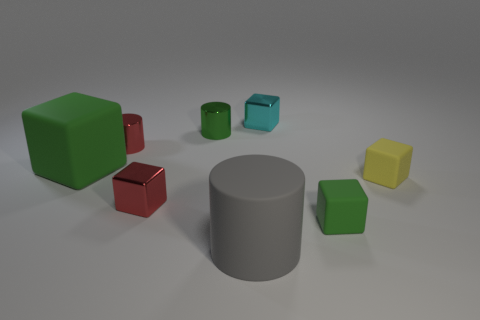Does the yellow rubber cube have the same size as the red cube?
Offer a very short reply. Yes. There is a matte cube on the right side of the green matte cube that is right of the tiny cyan metallic cube; what size is it?
Ensure brevity in your answer.  Small. What size is the thing that is behind the tiny red cylinder and on the right side of the green metallic thing?
Your response must be concise. Small. What number of green matte blocks have the same size as the yellow block?
Ensure brevity in your answer.  1. What number of metallic things are gray things or large yellow spheres?
Give a very brief answer. 0. There is a shiny object that is the same color as the big matte block; what is its size?
Ensure brevity in your answer.  Small. The green block in front of the large thing that is behind the gray rubber cylinder is made of what material?
Your response must be concise. Rubber. How many things are small green cylinders or small cubes in front of the small red shiny cylinder?
Your answer should be compact. 4. What is the size of the cyan cube that is the same material as the small red cylinder?
Ensure brevity in your answer.  Small. What number of green things are either shiny cylinders or small metallic cubes?
Offer a terse response. 1. 